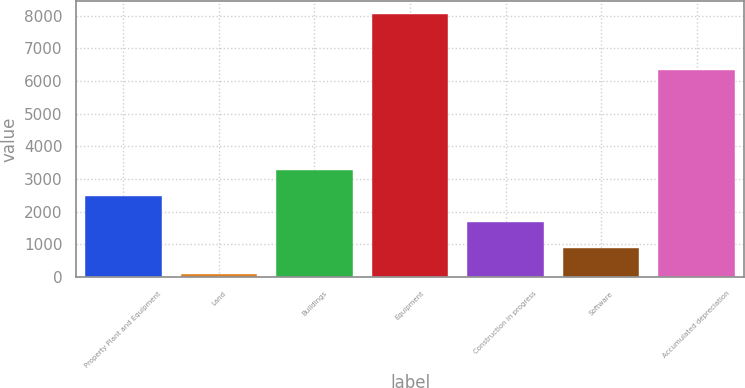Convert chart to OTSL. <chart><loc_0><loc_0><loc_500><loc_500><bar_chart><fcel>Property Plant and Equipment<fcel>Land<fcel>Buildings<fcel>Equipment<fcel>Construction in progress<fcel>Software<fcel>Accumulated depreciation<nl><fcel>2489.8<fcel>109<fcel>3283.4<fcel>8045<fcel>1696.2<fcel>902.6<fcel>6345<nl></chart> 